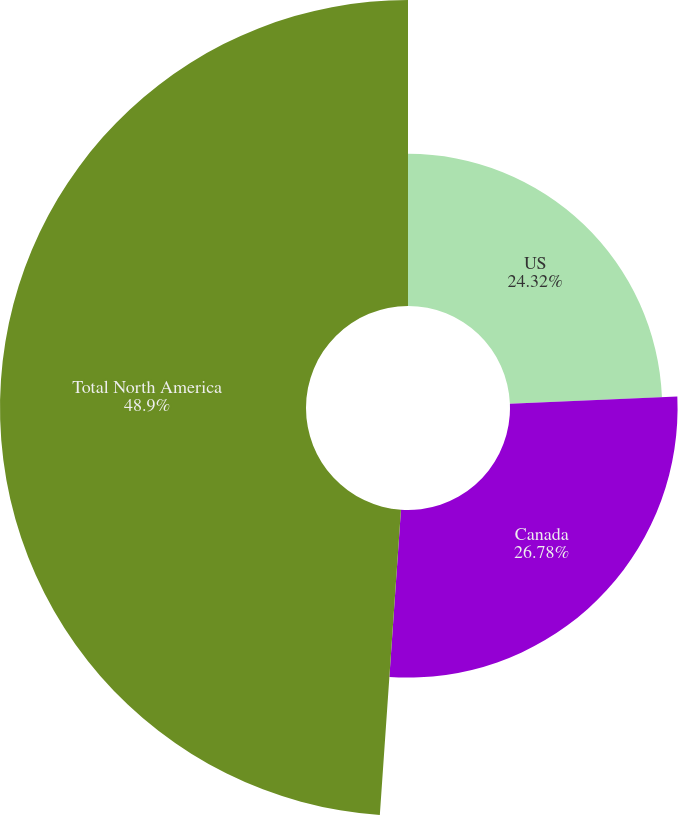<chart> <loc_0><loc_0><loc_500><loc_500><pie_chart><fcel>US<fcel>Canada<fcel>Total North America<nl><fcel>24.32%<fcel>26.78%<fcel>48.9%<nl></chart> 